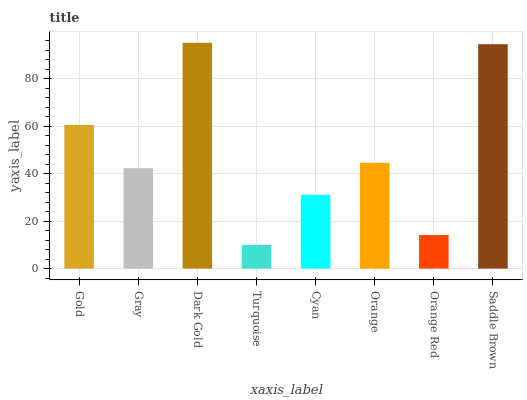Is Turquoise the minimum?
Answer yes or no. Yes. Is Dark Gold the maximum?
Answer yes or no. Yes. Is Gray the minimum?
Answer yes or no. No. Is Gray the maximum?
Answer yes or no. No. Is Gold greater than Gray?
Answer yes or no. Yes. Is Gray less than Gold?
Answer yes or no. Yes. Is Gray greater than Gold?
Answer yes or no. No. Is Gold less than Gray?
Answer yes or no. No. Is Orange the high median?
Answer yes or no. Yes. Is Gray the low median?
Answer yes or no. Yes. Is Orange Red the high median?
Answer yes or no. No. Is Dark Gold the low median?
Answer yes or no. No. 